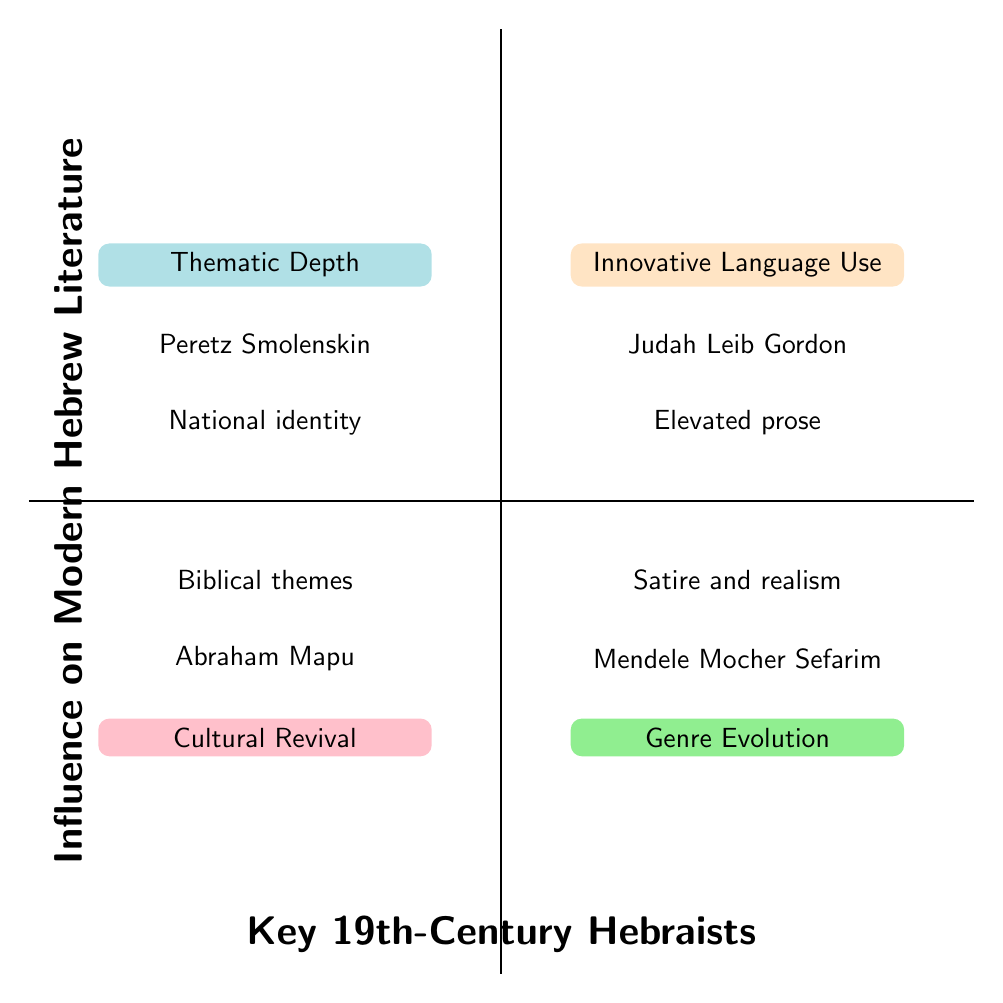What is the title of the top right quadrant? The top right quadrant corresponds to "Innovative Language Use," as indicated in the diagram.
Answer: Innovative Language Use Who is associated with "Cultural Revival"? The lower-left quadrant represents "Cultural Revival," and the author linked to this theme is Abraham Mapu.
Answer: Abraham Mapu What genre is Mendele Mocher Sefarim associated with? Mendele Mocher Sefarim is designated in the lower right quadrant as linked to "Satire and realism."
Answer: Satire and realism How many authors are mentioned in the quadrants? There are four authors listed, one in each quadrant, which includes Judah Leib Gordon, Peretz Smolenskin, Abraham Mapu, and Mendele Mocher Sefarim.
Answer: 4 Which hebraist emphasizes themes of national identity? In the upper left quadrant, Peretz Smolenskin is highlighted under the theme of "National identity."
Answer: Peretz Smolenskin Which quadrant includes elevated prose? Elevated prose is part of the top right quadrant labeled "Innovative Language Use," which features Judah Leib Gordon.
Answer: Innovative Language Use What is the theme associated with the lower left quadrant? The lower left quadrant is titled "Cultural Revival," and it prominently features biblical themes.
Answer: Cultural Revival Who reflects on thematic depth in Hebrew literature? Peretz Smolenskin, located in the upper left quadrant, represents the thematic depth in Hebrew literature with a focus on national identity.
Answer: Peretz Smolenskin 